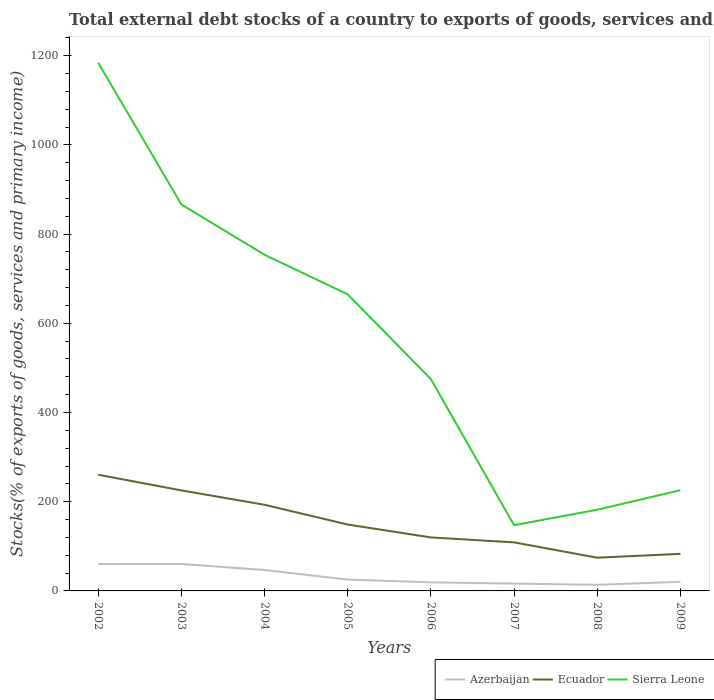Does the line corresponding to Ecuador intersect with the line corresponding to Azerbaijan?
Make the answer very short. No. Is the number of lines equal to the number of legend labels?
Make the answer very short. Yes. Across all years, what is the maximum total debt stocks in Azerbaijan?
Your response must be concise. 13.75. In which year was the total debt stocks in Ecuador maximum?
Provide a short and direct response. 2008. What is the total total debt stocks in Sierra Leone in the graph?
Offer a very short reply. 317.86. What is the difference between the highest and the second highest total debt stocks in Sierra Leone?
Provide a short and direct response. 1036.91. What is the difference between the highest and the lowest total debt stocks in Azerbaijan?
Offer a terse response. 3. Is the total debt stocks in Azerbaijan strictly greater than the total debt stocks in Ecuador over the years?
Offer a very short reply. Yes. How many lines are there?
Make the answer very short. 3. How many years are there in the graph?
Your response must be concise. 8. Where does the legend appear in the graph?
Provide a short and direct response. Bottom right. How many legend labels are there?
Keep it short and to the point. 3. What is the title of the graph?
Offer a terse response. Total external debt stocks of a country to exports of goods, services and primary income. Does "Croatia" appear as one of the legend labels in the graph?
Your answer should be very brief. No. What is the label or title of the X-axis?
Your response must be concise. Years. What is the label or title of the Y-axis?
Offer a terse response. Stocks(% of exports of goods, services and primary income). What is the Stocks(% of exports of goods, services and primary income) of Azerbaijan in 2002?
Your answer should be compact. 60.16. What is the Stocks(% of exports of goods, services and primary income) of Ecuador in 2002?
Offer a terse response. 260.5. What is the Stocks(% of exports of goods, services and primary income) of Sierra Leone in 2002?
Keep it short and to the point. 1184.31. What is the Stocks(% of exports of goods, services and primary income) in Azerbaijan in 2003?
Provide a short and direct response. 60.36. What is the Stocks(% of exports of goods, services and primary income) of Ecuador in 2003?
Give a very brief answer. 225.36. What is the Stocks(% of exports of goods, services and primary income) in Sierra Leone in 2003?
Make the answer very short. 866.46. What is the Stocks(% of exports of goods, services and primary income) of Azerbaijan in 2004?
Your answer should be very brief. 46.97. What is the Stocks(% of exports of goods, services and primary income) of Ecuador in 2004?
Your answer should be compact. 193.13. What is the Stocks(% of exports of goods, services and primary income) of Sierra Leone in 2004?
Give a very brief answer. 753.69. What is the Stocks(% of exports of goods, services and primary income) in Azerbaijan in 2005?
Give a very brief answer. 25.39. What is the Stocks(% of exports of goods, services and primary income) of Ecuador in 2005?
Offer a very short reply. 148.83. What is the Stocks(% of exports of goods, services and primary income) of Sierra Leone in 2005?
Your answer should be very brief. 664.88. What is the Stocks(% of exports of goods, services and primary income) of Azerbaijan in 2006?
Give a very brief answer. 19.2. What is the Stocks(% of exports of goods, services and primary income) of Ecuador in 2006?
Keep it short and to the point. 119.96. What is the Stocks(% of exports of goods, services and primary income) in Sierra Leone in 2006?
Provide a short and direct response. 474.84. What is the Stocks(% of exports of goods, services and primary income) of Azerbaijan in 2007?
Provide a short and direct response. 16.44. What is the Stocks(% of exports of goods, services and primary income) in Ecuador in 2007?
Provide a succinct answer. 108.87. What is the Stocks(% of exports of goods, services and primary income) of Sierra Leone in 2007?
Offer a very short reply. 147.41. What is the Stocks(% of exports of goods, services and primary income) in Azerbaijan in 2008?
Your answer should be very brief. 13.75. What is the Stocks(% of exports of goods, services and primary income) in Ecuador in 2008?
Provide a succinct answer. 74.46. What is the Stocks(% of exports of goods, services and primary income) of Sierra Leone in 2008?
Offer a very short reply. 182.07. What is the Stocks(% of exports of goods, services and primary income) in Azerbaijan in 2009?
Your response must be concise. 20.4. What is the Stocks(% of exports of goods, services and primary income) in Ecuador in 2009?
Your answer should be compact. 83.14. What is the Stocks(% of exports of goods, services and primary income) in Sierra Leone in 2009?
Your answer should be compact. 225.75. Across all years, what is the maximum Stocks(% of exports of goods, services and primary income) of Azerbaijan?
Your answer should be compact. 60.36. Across all years, what is the maximum Stocks(% of exports of goods, services and primary income) of Ecuador?
Offer a very short reply. 260.5. Across all years, what is the maximum Stocks(% of exports of goods, services and primary income) of Sierra Leone?
Provide a succinct answer. 1184.31. Across all years, what is the minimum Stocks(% of exports of goods, services and primary income) in Azerbaijan?
Ensure brevity in your answer.  13.75. Across all years, what is the minimum Stocks(% of exports of goods, services and primary income) in Ecuador?
Ensure brevity in your answer.  74.46. Across all years, what is the minimum Stocks(% of exports of goods, services and primary income) of Sierra Leone?
Ensure brevity in your answer.  147.41. What is the total Stocks(% of exports of goods, services and primary income) in Azerbaijan in the graph?
Ensure brevity in your answer.  262.67. What is the total Stocks(% of exports of goods, services and primary income) in Ecuador in the graph?
Your response must be concise. 1214.26. What is the total Stocks(% of exports of goods, services and primary income) of Sierra Leone in the graph?
Offer a terse response. 4499.4. What is the difference between the Stocks(% of exports of goods, services and primary income) of Azerbaijan in 2002 and that in 2003?
Provide a succinct answer. -0.19. What is the difference between the Stocks(% of exports of goods, services and primary income) in Ecuador in 2002 and that in 2003?
Provide a succinct answer. 35.14. What is the difference between the Stocks(% of exports of goods, services and primary income) of Sierra Leone in 2002 and that in 2003?
Make the answer very short. 317.86. What is the difference between the Stocks(% of exports of goods, services and primary income) in Azerbaijan in 2002 and that in 2004?
Your response must be concise. 13.2. What is the difference between the Stocks(% of exports of goods, services and primary income) of Ecuador in 2002 and that in 2004?
Provide a short and direct response. 67.37. What is the difference between the Stocks(% of exports of goods, services and primary income) in Sierra Leone in 2002 and that in 2004?
Offer a very short reply. 430.63. What is the difference between the Stocks(% of exports of goods, services and primary income) of Azerbaijan in 2002 and that in 2005?
Your response must be concise. 34.77. What is the difference between the Stocks(% of exports of goods, services and primary income) in Ecuador in 2002 and that in 2005?
Provide a short and direct response. 111.67. What is the difference between the Stocks(% of exports of goods, services and primary income) in Sierra Leone in 2002 and that in 2005?
Provide a short and direct response. 519.43. What is the difference between the Stocks(% of exports of goods, services and primary income) of Azerbaijan in 2002 and that in 2006?
Your answer should be very brief. 40.96. What is the difference between the Stocks(% of exports of goods, services and primary income) in Ecuador in 2002 and that in 2006?
Offer a very short reply. 140.54. What is the difference between the Stocks(% of exports of goods, services and primary income) of Sierra Leone in 2002 and that in 2006?
Keep it short and to the point. 709.48. What is the difference between the Stocks(% of exports of goods, services and primary income) in Azerbaijan in 2002 and that in 2007?
Make the answer very short. 43.73. What is the difference between the Stocks(% of exports of goods, services and primary income) of Ecuador in 2002 and that in 2007?
Keep it short and to the point. 151.63. What is the difference between the Stocks(% of exports of goods, services and primary income) of Sierra Leone in 2002 and that in 2007?
Provide a succinct answer. 1036.91. What is the difference between the Stocks(% of exports of goods, services and primary income) of Azerbaijan in 2002 and that in 2008?
Offer a very short reply. 46.42. What is the difference between the Stocks(% of exports of goods, services and primary income) of Ecuador in 2002 and that in 2008?
Your response must be concise. 186.04. What is the difference between the Stocks(% of exports of goods, services and primary income) of Sierra Leone in 2002 and that in 2008?
Make the answer very short. 1002.24. What is the difference between the Stocks(% of exports of goods, services and primary income) of Azerbaijan in 2002 and that in 2009?
Keep it short and to the point. 39.77. What is the difference between the Stocks(% of exports of goods, services and primary income) in Ecuador in 2002 and that in 2009?
Provide a succinct answer. 177.36. What is the difference between the Stocks(% of exports of goods, services and primary income) of Sierra Leone in 2002 and that in 2009?
Your answer should be compact. 958.57. What is the difference between the Stocks(% of exports of goods, services and primary income) in Azerbaijan in 2003 and that in 2004?
Your answer should be compact. 13.39. What is the difference between the Stocks(% of exports of goods, services and primary income) in Ecuador in 2003 and that in 2004?
Make the answer very short. 32.23. What is the difference between the Stocks(% of exports of goods, services and primary income) in Sierra Leone in 2003 and that in 2004?
Keep it short and to the point. 112.77. What is the difference between the Stocks(% of exports of goods, services and primary income) in Azerbaijan in 2003 and that in 2005?
Make the answer very short. 34.97. What is the difference between the Stocks(% of exports of goods, services and primary income) of Ecuador in 2003 and that in 2005?
Offer a terse response. 76.54. What is the difference between the Stocks(% of exports of goods, services and primary income) of Sierra Leone in 2003 and that in 2005?
Ensure brevity in your answer.  201.58. What is the difference between the Stocks(% of exports of goods, services and primary income) in Azerbaijan in 2003 and that in 2006?
Ensure brevity in your answer.  41.16. What is the difference between the Stocks(% of exports of goods, services and primary income) of Ecuador in 2003 and that in 2006?
Your answer should be compact. 105.4. What is the difference between the Stocks(% of exports of goods, services and primary income) of Sierra Leone in 2003 and that in 2006?
Make the answer very short. 391.62. What is the difference between the Stocks(% of exports of goods, services and primary income) of Azerbaijan in 2003 and that in 2007?
Offer a very short reply. 43.92. What is the difference between the Stocks(% of exports of goods, services and primary income) of Ecuador in 2003 and that in 2007?
Offer a terse response. 116.49. What is the difference between the Stocks(% of exports of goods, services and primary income) in Sierra Leone in 2003 and that in 2007?
Provide a succinct answer. 719.05. What is the difference between the Stocks(% of exports of goods, services and primary income) in Azerbaijan in 2003 and that in 2008?
Give a very brief answer. 46.61. What is the difference between the Stocks(% of exports of goods, services and primary income) of Ecuador in 2003 and that in 2008?
Your answer should be very brief. 150.9. What is the difference between the Stocks(% of exports of goods, services and primary income) of Sierra Leone in 2003 and that in 2008?
Ensure brevity in your answer.  684.39. What is the difference between the Stocks(% of exports of goods, services and primary income) in Azerbaijan in 2003 and that in 2009?
Give a very brief answer. 39.96. What is the difference between the Stocks(% of exports of goods, services and primary income) of Ecuador in 2003 and that in 2009?
Your answer should be compact. 142.22. What is the difference between the Stocks(% of exports of goods, services and primary income) of Sierra Leone in 2003 and that in 2009?
Give a very brief answer. 640.71. What is the difference between the Stocks(% of exports of goods, services and primary income) of Azerbaijan in 2004 and that in 2005?
Ensure brevity in your answer.  21.57. What is the difference between the Stocks(% of exports of goods, services and primary income) in Ecuador in 2004 and that in 2005?
Ensure brevity in your answer.  44.31. What is the difference between the Stocks(% of exports of goods, services and primary income) in Sierra Leone in 2004 and that in 2005?
Keep it short and to the point. 88.81. What is the difference between the Stocks(% of exports of goods, services and primary income) in Azerbaijan in 2004 and that in 2006?
Offer a very short reply. 27.76. What is the difference between the Stocks(% of exports of goods, services and primary income) of Ecuador in 2004 and that in 2006?
Your answer should be very brief. 73.17. What is the difference between the Stocks(% of exports of goods, services and primary income) in Sierra Leone in 2004 and that in 2006?
Provide a succinct answer. 278.85. What is the difference between the Stocks(% of exports of goods, services and primary income) of Azerbaijan in 2004 and that in 2007?
Provide a succinct answer. 30.53. What is the difference between the Stocks(% of exports of goods, services and primary income) in Ecuador in 2004 and that in 2007?
Offer a very short reply. 84.26. What is the difference between the Stocks(% of exports of goods, services and primary income) of Sierra Leone in 2004 and that in 2007?
Your answer should be very brief. 606.28. What is the difference between the Stocks(% of exports of goods, services and primary income) of Azerbaijan in 2004 and that in 2008?
Your answer should be compact. 33.22. What is the difference between the Stocks(% of exports of goods, services and primary income) in Ecuador in 2004 and that in 2008?
Your answer should be compact. 118.67. What is the difference between the Stocks(% of exports of goods, services and primary income) of Sierra Leone in 2004 and that in 2008?
Your response must be concise. 571.62. What is the difference between the Stocks(% of exports of goods, services and primary income) in Azerbaijan in 2004 and that in 2009?
Keep it short and to the point. 26.57. What is the difference between the Stocks(% of exports of goods, services and primary income) in Ecuador in 2004 and that in 2009?
Offer a terse response. 109.99. What is the difference between the Stocks(% of exports of goods, services and primary income) of Sierra Leone in 2004 and that in 2009?
Provide a short and direct response. 527.94. What is the difference between the Stocks(% of exports of goods, services and primary income) in Azerbaijan in 2005 and that in 2006?
Your answer should be very brief. 6.19. What is the difference between the Stocks(% of exports of goods, services and primary income) of Ecuador in 2005 and that in 2006?
Offer a very short reply. 28.87. What is the difference between the Stocks(% of exports of goods, services and primary income) of Sierra Leone in 2005 and that in 2006?
Keep it short and to the point. 190.05. What is the difference between the Stocks(% of exports of goods, services and primary income) in Azerbaijan in 2005 and that in 2007?
Give a very brief answer. 8.96. What is the difference between the Stocks(% of exports of goods, services and primary income) of Ecuador in 2005 and that in 2007?
Your response must be concise. 39.95. What is the difference between the Stocks(% of exports of goods, services and primary income) in Sierra Leone in 2005 and that in 2007?
Keep it short and to the point. 517.48. What is the difference between the Stocks(% of exports of goods, services and primary income) in Azerbaijan in 2005 and that in 2008?
Provide a succinct answer. 11.65. What is the difference between the Stocks(% of exports of goods, services and primary income) in Ecuador in 2005 and that in 2008?
Make the answer very short. 74.36. What is the difference between the Stocks(% of exports of goods, services and primary income) of Sierra Leone in 2005 and that in 2008?
Make the answer very short. 482.81. What is the difference between the Stocks(% of exports of goods, services and primary income) in Azerbaijan in 2005 and that in 2009?
Provide a short and direct response. 5. What is the difference between the Stocks(% of exports of goods, services and primary income) in Ecuador in 2005 and that in 2009?
Make the answer very short. 65.68. What is the difference between the Stocks(% of exports of goods, services and primary income) of Sierra Leone in 2005 and that in 2009?
Ensure brevity in your answer.  439.14. What is the difference between the Stocks(% of exports of goods, services and primary income) of Azerbaijan in 2006 and that in 2007?
Ensure brevity in your answer.  2.77. What is the difference between the Stocks(% of exports of goods, services and primary income) in Ecuador in 2006 and that in 2007?
Ensure brevity in your answer.  11.09. What is the difference between the Stocks(% of exports of goods, services and primary income) of Sierra Leone in 2006 and that in 2007?
Provide a succinct answer. 327.43. What is the difference between the Stocks(% of exports of goods, services and primary income) in Azerbaijan in 2006 and that in 2008?
Your answer should be very brief. 5.46. What is the difference between the Stocks(% of exports of goods, services and primary income) in Ecuador in 2006 and that in 2008?
Your response must be concise. 45.5. What is the difference between the Stocks(% of exports of goods, services and primary income) of Sierra Leone in 2006 and that in 2008?
Keep it short and to the point. 292.77. What is the difference between the Stocks(% of exports of goods, services and primary income) of Azerbaijan in 2006 and that in 2009?
Give a very brief answer. -1.19. What is the difference between the Stocks(% of exports of goods, services and primary income) in Ecuador in 2006 and that in 2009?
Provide a short and direct response. 36.82. What is the difference between the Stocks(% of exports of goods, services and primary income) of Sierra Leone in 2006 and that in 2009?
Your response must be concise. 249.09. What is the difference between the Stocks(% of exports of goods, services and primary income) in Azerbaijan in 2007 and that in 2008?
Give a very brief answer. 2.69. What is the difference between the Stocks(% of exports of goods, services and primary income) of Ecuador in 2007 and that in 2008?
Make the answer very short. 34.41. What is the difference between the Stocks(% of exports of goods, services and primary income) in Sierra Leone in 2007 and that in 2008?
Offer a very short reply. -34.66. What is the difference between the Stocks(% of exports of goods, services and primary income) of Azerbaijan in 2007 and that in 2009?
Offer a terse response. -3.96. What is the difference between the Stocks(% of exports of goods, services and primary income) in Ecuador in 2007 and that in 2009?
Offer a terse response. 25.73. What is the difference between the Stocks(% of exports of goods, services and primary income) in Sierra Leone in 2007 and that in 2009?
Ensure brevity in your answer.  -78.34. What is the difference between the Stocks(% of exports of goods, services and primary income) in Azerbaijan in 2008 and that in 2009?
Give a very brief answer. -6.65. What is the difference between the Stocks(% of exports of goods, services and primary income) of Ecuador in 2008 and that in 2009?
Your answer should be compact. -8.68. What is the difference between the Stocks(% of exports of goods, services and primary income) of Sierra Leone in 2008 and that in 2009?
Ensure brevity in your answer.  -43.68. What is the difference between the Stocks(% of exports of goods, services and primary income) of Azerbaijan in 2002 and the Stocks(% of exports of goods, services and primary income) of Ecuador in 2003?
Your response must be concise. -165.2. What is the difference between the Stocks(% of exports of goods, services and primary income) of Azerbaijan in 2002 and the Stocks(% of exports of goods, services and primary income) of Sierra Leone in 2003?
Offer a very short reply. -806.29. What is the difference between the Stocks(% of exports of goods, services and primary income) in Ecuador in 2002 and the Stocks(% of exports of goods, services and primary income) in Sierra Leone in 2003?
Provide a short and direct response. -605.96. What is the difference between the Stocks(% of exports of goods, services and primary income) of Azerbaijan in 2002 and the Stocks(% of exports of goods, services and primary income) of Ecuador in 2004?
Your response must be concise. -132.97. What is the difference between the Stocks(% of exports of goods, services and primary income) of Azerbaijan in 2002 and the Stocks(% of exports of goods, services and primary income) of Sierra Leone in 2004?
Your response must be concise. -693.52. What is the difference between the Stocks(% of exports of goods, services and primary income) of Ecuador in 2002 and the Stocks(% of exports of goods, services and primary income) of Sierra Leone in 2004?
Offer a terse response. -493.19. What is the difference between the Stocks(% of exports of goods, services and primary income) of Azerbaijan in 2002 and the Stocks(% of exports of goods, services and primary income) of Ecuador in 2005?
Your answer should be compact. -88.66. What is the difference between the Stocks(% of exports of goods, services and primary income) of Azerbaijan in 2002 and the Stocks(% of exports of goods, services and primary income) of Sierra Leone in 2005?
Your answer should be very brief. -604.72. What is the difference between the Stocks(% of exports of goods, services and primary income) of Ecuador in 2002 and the Stocks(% of exports of goods, services and primary income) of Sierra Leone in 2005?
Provide a succinct answer. -404.38. What is the difference between the Stocks(% of exports of goods, services and primary income) in Azerbaijan in 2002 and the Stocks(% of exports of goods, services and primary income) in Ecuador in 2006?
Provide a succinct answer. -59.79. What is the difference between the Stocks(% of exports of goods, services and primary income) in Azerbaijan in 2002 and the Stocks(% of exports of goods, services and primary income) in Sierra Leone in 2006?
Provide a short and direct response. -414.67. What is the difference between the Stocks(% of exports of goods, services and primary income) in Ecuador in 2002 and the Stocks(% of exports of goods, services and primary income) in Sierra Leone in 2006?
Keep it short and to the point. -214.34. What is the difference between the Stocks(% of exports of goods, services and primary income) in Azerbaijan in 2002 and the Stocks(% of exports of goods, services and primary income) in Ecuador in 2007?
Make the answer very short. -48.71. What is the difference between the Stocks(% of exports of goods, services and primary income) in Azerbaijan in 2002 and the Stocks(% of exports of goods, services and primary income) in Sierra Leone in 2007?
Provide a succinct answer. -87.24. What is the difference between the Stocks(% of exports of goods, services and primary income) of Ecuador in 2002 and the Stocks(% of exports of goods, services and primary income) of Sierra Leone in 2007?
Ensure brevity in your answer.  113.09. What is the difference between the Stocks(% of exports of goods, services and primary income) of Azerbaijan in 2002 and the Stocks(% of exports of goods, services and primary income) of Ecuador in 2008?
Keep it short and to the point. -14.3. What is the difference between the Stocks(% of exports of goods, services and primary income) of Azerbaijan in 2002 and the Stocks(% of exports of goods, services and primary income) of Sierra Leone in 2008?
Provide a succinct answer. -121.9. What is the difference between the Stocks(% of exports of goods, services and primary income) in Ecuador in 2002 and the Stocks(% of exports of goods, services and primary income) in Sierra Leone in 2008?
Your answer should be very brief. 78.43. What is the difference between the Stocks(% of exports of goods, services and primary income) of Azerbaijan in 2002 and the Stocks(% of exports of goods, services and primary income) of Ecuador in 2009?
Make the answer very short. -22.98. What is the difference between the Stocks(% of exports of goods, services and primary income) of Azerbaijan in 2002 and the Stocks(% of exports of goods, services and primary income) of Sierra Leone in 2009?
Your answer should be compact. -165.58. What is the difference between the Stocks(% of exports of goods, services and primary income) in Ecuador in 2002 and the Stocks(% of exports of goods, services and primary income) in Sierra Leone in 2009?
Offer a very short reply. 34.75. What is the difference between the Stocks(% of exports of goods, services and primary income) of Azerbaijan in 2003 and the Stocks(% of exports of goods, services and primary income) of Ecuador in 2004?
Make the answer very short. -132.77. What is the difference between the Stocks(% of exports of goods, services and primary income) in Azerbaijan in 2003 and the Stocks(% of exports of goods, services and primary income) in Sierra Leone in 2004?
Keep it short and to the point. -693.33. What is the difference between the Stocks(% of exports of goods, services and primary income) of Ecuador in 2003 and the Stocks(% of exports of goods, services and primary income) of Sierra Leone in 2004?
Offer a very short reply. -528.33. What is the difference between the Stocks(% of exports of goods, services and primary income) of Azerbaijan in 2003 and the Stocks(% of exports of goods, services and primary income) of Ecuador in 2005?
Keep it short and to the point. -88.47. What is the difference between the Stocks(% of exports of goods, services and primary income) of Azerbaijan in 2003 and the Stocks(% of exports of goods, services and primary income) of Sierra Leone in 2005?
Your answer should be very brief. -604.52. What is the difference between the Stocks(% of exports of goods, services and primary income) in Ecuador in 2003 and the Stocks(% of exports of goods, services and primary income) in Sierra Leone in 2005?
Provide a succinct answer. -439.52. What is the difference between the Stocks(% of exports of goods, services and primary income) in Azerbaijan in 2003 and the Stocks(% of exports of goods, services and primary income) in Ecuador in 2006?
Give a very brief answer. -59.6. What is the difference between the Stocks(% of exports of goods, services and primary income) of Azerbaijan in 2003 and the Stocks(% of exports of goods, services and primary income) of Sierra Leone in 2006?
Provide a short and direct response. -414.48. What is the difference between the Stocks(% of exports of goods, services and primary income) in Ecuador in 2003 and the Stocks(% of exports of goods, services and primary income) in Sierra Leone in 2006?
Your response must be concise. -249.47. What is the difference between the Stocks(% of exports of goods, services and primary income) of Azerbaijan in 2003 and the Stocks(% of exports of goods, services and primary income) of Ecuador in 2007?
Your response must be concise. -48.51. What is the difference between the Stocks(% of exports of goods, services and primary income) of Azerbaijan in 2003 and the Stocks(% of exports of goods, services and primary income) of Sierra Leone in 2007?
Keep it short and to the point. -87.05. What is the difference between the Stocks(% of exports of goods, services and primary income) of Ecuador in 2003 and the Stocks(% of exports of goods, services and primary income) of Sierra Leone in 2007?
Give a very brief answer. 77.95. What is the difference between the Stocks(% of exports of goods, services and primary income) of Azerbaijan in 2003 and the Stocks(% of exports of goods, services and primary income) of Ecuador in 2008?
Your answer should be very brief. -14.1. What is the difference between the Stocks(% of exports of goods, services and primary income) of Azerbaijan in 2003 and the Stocks(% of exports of goods, services and primary income) of Sierra Leone in 2008?
Offer a very short reply. -121.71. What is the difference between the Stocks(% of exports of goods, services and primary income) in Ecuador in 2003 and the Stocks(% of exports of goods, services and primary income) in Sierra Leone in 2008?
Keep it short and to the point. 43.29. What is the difference between the Stocks(% of exports of goods, services and primary income) of Azerbaijan in 2003 and the Stocks(% of exports of goods, services and primary income) of Ecuador in 2009?
Provide a succinct answer. -22.78. What is the difference between the Stocks(% of exports of goods, services and primary income) in Azerbaijan in 2003 and the Stocks(% of exports of goods, services and primary income) in Sierra Leone in 2009?
Give a very brief answer. -165.39. What is the difference between the Stocks(% of exports of goods, services and primary income) in Ecuador in 2003 and the Stocks(% of exports of goods, services and primary income) in Sierra Leone in 2009?
Give a very brief answer. -0.39. What is the difference between the Stocks(% of exports of goods, services and primary income) of Azerbaijan in 2004 and the Stocks(% of exports of goods, services and primary income) of Ecuador in 2005?
Keep it short and to the point. -101.86. What is the difference between the Stocks(% of exports of goods, services and primary income) of Azerbaijan in 2004 and the Stocks(% of exports of goods, services and primary income) of Sierra Leone in 2005?
Give a very brief answer. -617.91. What is the difference between the Stocks(% of exports of goods, services and primary income) of Ecuador in 2004 and the Stocks(% of exports of goods, services and primary income) of Sierra Leone in 2005?
Offer a terse response. -471.75. What is the difference between the Stocks(% of exports of goods, services and primary income) in Azerbaijan in 2004 and the Stocks(% of exports of goods, services and primary income) in Ecuador in 2006?
Provide a short and direct response. -72.99. What is the difference between the Stocks(% of exports of goods, services and primary income) in Azerbaijan in 2004 and the Stocks(% of exports of goods, services and primary income) in Sierra Leone in 2006?
Provide a succinct answer. -427.87. What is the difference between the Stocks(% of exports of goods, services and primary income) in Ecuador in 2004 and the Stocks(% of exports of goods, services and primary income) in Sierra Leone in 2006?
Offer a terse response. -281.7. What is the difference between the Stocks(% of exports of goods, services and primary income) of Azerbaijan in 2004 and the Stocks(% of exports of goods, services and primary income) of Ecuador in 2007?
Give a very brief answer. -61.9. What is the difference between the Stocks(% of exports of goods, services and primary income) of Azerbaijan in 2004 and the Stocks(% of exports of goods, services and primary income) of Sierra Leone in 2007?
Provide a succinct answer. -100.44. What is the difference between the Stocks(% of exports of goods, services and primary income) of Ecuador in 2004 and the Stocks(% of exports of goods, services and primary income) of Sierra Leone in 2007?
Your answer should be very brief. 45.73. What is the difference between the Stocks(% of exports of goods, services and primary income) of Azerbaijan in 2004 and the Stocks(% of exports of goods, services and primary income) of Ecuador in 2008?
Provide a succinct answer. -27.5. What is the difference between the Stocks(% of exports of goods, services and primary income) of Azerbaijan in 2004 and the Stocks(% of exports of goods, services and primary income) of Sierra Leone in 2008?
Offer a terse response. -135.1. What is the difference between the Stocks(% of exports of goods, services and primary income) of Ecuador in 2004 and the Stocks(% of exports of goods, services and primary income) of Sierra Leone in 2008?
Provide a short and direct response. 11.06. What is the difference between the Stocks(% of exports of goods, services and primary income) of Azerbaijan in 2004 and the Stocks(% of exports of goods, services and primary income) of Ecuador in 2009?
Offer a terse response. -36.17. What is the difference between the Stocks(% of exports of goods, services and primary income) of Azerbaijan in 2004 and the Stocks(% of exports of goods, services and primary income) of Sierra Leone in 2009?
Offer a very short reply. -178.78. What is the difference between the Stocks(% of exports of goods, services and primary income) in Ecuador in 2004 and the Stocks(% of exports of goods, services and primary income) in Sierra Leone in 2009?
Your answer should be compact. -32.61. What is the difference between the Stocks(% of exports of goods, services and primary income) of Azerbaijan in 2005 and the Stocks(% of exports of goods, services and primary income) of Ecuador in 2006?
Give a very brief answer. -94.57. What is the difference between the Stocks(% of exports of goods, services and primary income) in Azerbaijan in 2005 and the Stocks(% of exports of goods, services and primary income) in Sierra Leone in 2006?
Keep it short and to the point. -449.44. What is the difference between the Stocks(% of exports of goods, services and primary income) in Ecuador in 2005 and the Stocks(% of exports of goods, services and primary income) in Sierra Leone in 2006?
Keep it short and to the point. -326.01. What is the difference between the Stocks(% of exports of goods, services and primary income) in Azerbaijan in 2005 and the Stocks(% of exports of goods, services and primary income) in Ecuador in 2007?
Provide a succinct answer. -83.48. What is the difference between the Stocks(% of exports of goods, services and primary income) in Azerbaijan in 2005 and the Stocks(% of exports of goods, services and primary income) in Sierra Leone in 2007?
Your response must be concise. -122.01. What is the difference between the Stocks(% of exports of goods, services and primary income) of Ecuador in 2005 and the Stocks(% of exports of goods, services and primary income) of Sierra Leone in 2007?
Offer a terse response. 1.42. What is the difference between the Stocks(% of exports of goods, services and primary income) of Azerbaijan in 2005 and the Stocks(% of exports of goods, services and primary income) of Ecuador in 2008?
Offer a terse response. -49.07. What is the difference between the Stocks(% of exports of goods, services and primary income) of Azerbaijan in 2005 and the Stocks(% of exports of goods, services and primary income) of Sierra Leone in 2008?
Make the answer very short. -156.68. What is the difference between the Stocks(% of exports of goods, services and primary income) in Ecuador in 2005 and the Stocks(% of exports of goods, services and primary income) in Sierra Leone in 2008?
Offer a very short reply. -33.24. What is the difference between the Stocks(% of exports of goods, services and primary income) in Azerbaijan in 2005 and the Stocks(% of exports of goods, services and primary income) in Ecuador in 2009?
Your response must be concise. -57.75. What is the difference between the Stocks(% of exports of goods, services and primary income) in Azerbaijan in 2005 and the Stocks(% of exports of goods, services and primary income) in Sierra Leone in 2009?
Keep it short and to the point. -200.35. What is the difference between the Stocks(% of exports of goods, services and primary income) in Ecuador in 2005 and the Stocks(% of exports of goods, services and primary income) in Sierra Leone in 2009?
Provide a short and direct response. -76.92. What is the difference between the Stocks(% of exports of goods, services and primary income) in Azerbaijan in 2006 and the Stocks(% of exports of goods, services and primary income) in Ecuador in 2007?
Offer a very short reply. -89.67. What is the difference between the Stocks(% of exports of goods, services and primary income) in Azerbaijan in 2006 and the Stocks(% of exports of goods, services and primary income) in Sierra Leone in 2007?
Ensure brevity in your answer.  -128.2. What is the difference between the Stocks(% of exports of goods, services and primary income) of Ecuador in 2006 and the Stocks(% of exports of goods, services and primary income) of Sierra Leone in 2007?
Offer a very short reply. -27.45. What is the difference between the Stocks(% of exports of goods, services and primary income) of Azerbaijan in 2006 and the Stocks(% of exports of goods, services and primary income) of Ecuador in 2008?
Your answer should be very brief. -55.26. What is the difference between the Stocks(% of exports of goods, services and primary income) in Azerbaijan in 2006 and the Stocks(% of exports of goods, services and primary income) in Sierra Leone in 2008?
Provide a succinct answer. -162.87. What is the difference between the Stocks(% of exports of goods, services and primary income) of Ecuador in 2006 and the Stocks(% of exports of goods, services and primary income) of Sierra Leone in 2008?
Offer a very short reply. -62.11. What is the difference between the Stocks(% of exports of goods, services and primary income) in Azerbaijan in 2006 and the Stocks(% of exports of goods, services and primary income) in Ecuador in 2009?
Your answer should be very brief. -63.94. What is the difference between the Stocks(% of exports of goods, services and primary income) in Azerbaijan in 2006 and the Stocks(% of exports of goods, services and primary income) in Sierra Leone in 2009?
Your answer should be compact. -206.54. What is the difference between the Stocks(% of exports of goods, services and primary income) in Ecuador in 2006 and the Stocks(% of exports of goods, services and primary income) in Sierra Leone in 2009?
Keep it short and to the point. -105.79. What is the difference between the Stocks(% of exports of goods, services and primary income) in Azerbaijan in 2007 and the Stocks(% of exports of goods, services and primary income) in Ecuador in 2008?
Your response must be concise. -58.03. What is the difference between the Stocks(% of exports of goods, services and primary income) in Azerbaijan in 2007 and the Stocks(% of exports of goods, services and primary income) in Sierra Leone in 2008?
Your answer should be very brief. -165.63. What is the difference between the Stocks(% of exports of goods, services and primary income) of Ecuador in 2007 and the Stocks(% of exports of goods, services and primary income) of Sierra Leone in 2008?
Offer a very short reply. -73.2. What is the difference between the Stocks(% of exports of goods, services and primary income) in Azerbaijan in 2007 and the Stocks(% of exports of goods, services and primary income) in Ecuador in 2009?
Keep it short and to the point. -66.7. What is the difference between the Stocks(% of exports of goods, services and primary income) in Azerbaijan in 2007 and the Stocks(% of exports of goods, services and primary income) in Sierra Leone in 2009?
Your answer should be compact. -209.31. What is the difference between the Stocks(% of exports of goods, services and primary income) in Ecuador in 2007 and the Stocks(% of exports of goods, services and primary income) in Sierra Leone in 2009?
Offer a terse response. -116.88. What is the difference between the Stocks(% of exports of goods, services and primary income) in Azerbaijan in 2008 and the Stocks(% of exports of goods, services and primary income) in Ecuador in 2009?
Your answer should be compact. -69.39. What is the difference between the Stocks(% of exports of goods, services and primary income) of Azerbaijan in 2008 and the Stocks(% of exports of goods, services and primary income) of Sierra Leone in 2009?
Your response must be concise. -212. What is the difference between the Stocks(% of exports of goods, services and primary income) of Ecuador in 2008 and the Stocks(% of exports of goods, services and primary income) of Sierra Leone in 2009?
Keep it short and to the point. -151.28. What is the average Stocks(% of exports of goods, services and primary income) in Azerbaijan per year?
Make the answer very short. 32.83. What is the average Stocks(% of exports of goods, services and primary income) in Ecuador per year?
Ensure brevity in your answer.  151.78. What is the average Stocks(% of exports of goods, services and primary income) in Sierra Leone per year?
Ensure brevity in your answer.  562.43. In the year 2002, what is the difference between the Stocks(% of exports of goods, services and primary income) of Azerbaijan and Stocks(% of exports of goods, services and primary income) of Ecuador?
Offer a very short reply. -200.33. In the year 2002, what is the difference between the Stocks(% of exports of goods, services and primary income) in Azerbaijan and Stocks(% of exports of goods, services and primary income) in Sierra Leone?
Your answer should be compact. -1124.15. In the year 2002, what is the difference between the Stocks(% of exports of goods, services and primary income) in Ecuador and Stocks(% of exports of goods, services and primary income) in Sierra Leone?
Your response must be concise. -923.81. In the year 2003, what is the difference between the Stocks(% of exports of goods, services and primary income) of Azerbaijan and Stocks(% of exports of goods, services and primary income) of Ecuador?
Provide a short and direct response. -165. In the year 2003, what is the difference between the Stocks(% of exports of goods, services and primary income) of Azerbaijan and Stocks(% of exports of goods, services and primary income) of Sierra Leone?
Keep it short and to the point. -806.1. In the year 2003, what is the difference between the Stocks(% of exports of goods, services and primary income) of Ecuador and Stocks(% of exports of goods, services and primary income) of Sierra Leone?
Provide a short and direct response. -641.1. In the year 2004, what is the difference between the Stocks(% of exports of goods, services and primary income) of Azerbaijan and Stocks(% of exports of goods, services and primary income) of Ecuador?
Provide a succinct answer. -146.17. In the year 2004, what is the difference between the Stocks(% of exports of goods, services and primary income) of Azerbaijan and Stocks(% of exports of goods, services and primary income) of Sierra Leone?
Provide a short and direct response. -706.72. In the year 2004, what is the difference between the Stocks(% of exports of goods, services and primary income) in Ecuador and Stocks(% of exports of goods, services and primary income) in Sierra Leone?
Offer a terse response. -560.55. In the year 2005, what is the difference between the Stocks(% of exports of goods, services and primary income) of Azerbaijan and Stocks(% of exports of goods, services and primary income) of Ecuador?
Your answer should be compact. -123.43. In the year 2005, what is the difference between the Stocks(% of exports of goods, services and primary income) of Azerbaijan and Stocks(% of exports of goods, services and primary income) of Sierra Leone?
Provide a short and direct response. -639.49. In the year 2005, what is the difference between the Stocks(% of exports of goods, services and primary income) of Ecuador and Stocks(% of exports of goods, services and primary income) of Sierra Leone?
Give a very brief answer. -516.06. In the year 2006, what is the difference between the Stocks(% of exports of goods, services and primary income) in Azerbaijan and Stocks(% of exports of goods, services and primary income) in Ecuador?
Give a very brief answer. -100.76. In the year 2006, what is the difference between the Stocks(% of exports of goods, services and primary income) in Azerbaijan and Stocks(% of exports of goods, services and primary income) in Sierra Leone?
Your answer should be compact. -455.63. In the year 2006, what is the difference between the Stocks(% of exports of goods, services and primary income) in Ecuador and Stocks(% of exports of goods, services and primary income) in Sierra Leone?
Your response must be concise. -354.88. In the year 2007, what is the difference between the Stocks(% of exports of goods, services and primary income) in Azerbaijan and Stocks(% of exports of goods, services and primary income) in Ecuador?
Your response must be concise. -92.43. In the year 2007, what is the difference between the Stocks(% of exports of goods, services and primary income) of Azerbaijan and Stocks(% of exports of goods, services and primary income) of Sierra Leone?
Your answer should be very brief. -130.97. In the year 2007, what is the difference between the Stocks(% of exports of goods, services and primary income) in Ecuador and Stocks(% of exports of goods, services and primary income) in Sierra Leone?
Keep it short and to the point. -38.54. In the year 2008, what is the difference between the Stocks(% of exports of goods, services and primary income) of Azerbaijan and Stocks(% of exports of goods, services and primary income) of Ecuador?
Ensure brevity in your answer.  -60.72. In the year 2008, what is the difference between the Stocks(% of exports of goods, services and primary income) in Azerbaijan and Stocks(% of exports of goods, services and primary income) in Sierra Leone?
Your answer should be compact. -168.32. In the year 2008, what is the difference between the Stocks(% of exports of goods, services and primary income) in Ecuador and Stocks(% of exports of goods, services and primary income) in Sierra Leone?
Make the answer very short. -107.61. In the year 2009, what is the difference between the Stocks(% of exports of goods, services and primary income) of Azerbaijan and Stocks(% of exports of goods, services and primary income) of Ecuador?
Provide a short and direct response. -62.75. In the year 2009, what is the difference between the Stocks(% of exports of goods, services and primary income) of Azerbaijan and Stocks(% of exports of goods, services and primary income) of Sierra Leone?
Provide a succinct answer. -205.35. In the year 2009, what is the difference between the Stocks(% of exports of goods, services and primary income) in Ecuador and Stocks(% of exports of goods, services and primary income) in Sierra Leone?
Ensure brevity in your answer.  -142.61. What is the ratio of the Stocks(% of exports of goods, services and primary income) in Ecuador in 2002 to that in 2003?
Offer a terse response. 1.16. What is the ratio of the Stocks(% of exports of goods, services and primary income) in Sierra Leone in 2002 to that in 2003?
Make the answer very short. 1.37. What is the ratio of the Stocks(% of exports of goods, services and primary income) of Azerbaijan in 2002 to that in 2004?
Make the answer very short. 1.28. What is the ratio of the Stocks(% of exports of goods, services and primary income) of Ecuador in 2002 to that in 2004?
Give a very brief answer. 1.35. What is the ratio of the Stocks(% of exports of goods, services and primary income) in Sierra Leone in 2002 to that in 2004?
Ensure brevity in your answer.  1.57. What is the ratio of the Stocks(% of exports of goods, services and primary income) of Azerbaijan in 2002 to that in 2005?
Your answer should be very brief. 2.37. What is the ratio of the Stocks(% of exports of goods, services and primary income) in Ecuador in 2002 to that in 2005?
Offer a terse response. 1.75. What is the ratio of the Stocks(% of exports of goods, services and primary income) in Sierra Leone in 2002 to that in 2005?
Offer a very short reply. 1.78. What is the ratio of the Stocks(% of exports of goods, services and primary income) of Azerbaijan in 2002 to that in 2006?
Provide a succinct answer. 3.13. What is the ratio of the Stocks(% of exports of goods, services and primary income) of Ecuador in 2002 to that in 2006?
Offer a terse response. 2.17. What is the ratio of the Stocks(% of exports of goods, services and primary income) of Sierra Leone in 2002 to that in 2006?
Provide a short and direct response. 2.49. What is the ratio of the Stocks(% of exports of goods, services and primary income) of Azerbaijan in 2002 to that in 2007?
Ensure brevity in your answer.  3.66. What is the ratio of the Stocks(% of exports of goods, services and primary income) of Ecuador in 2002 to that in 2007?
Offer a very short reply. 2.39. What is the ratio of the Stocks(% of exports of goods, services and primary income) in Sierra Leone in 2002 to that in 2007?
Make the answer very short. 8.03. What is the ratio of the Stocks(% of exports of goods, services and primary income) in Azerbaijan in 2002 to that in 2008?
Offer a terse response. 4.38. What is the ratio of the Stocks(% of exports of goods, services and primary income) of Ecuador in 2002 to that in 2008?
Keep it short and to the point. 3.5. What is the ratio of the Stocks(% of exports of goods, services and primary income) of Sierra Leone in 2002 to that in 2008?
Your answer should be very brief. 6.5. What is the ratio of the Stocks(% of exports of goods, services and primary income) in Azerbaijan in 2002 to that in 2009?
Make the answer very short. 2.95. What is the ratio of the Stocks(% of exports of goods, services and primary income) of Ecuador in 2002 to that in 2009?
Ensure brevity in your answer.  3.13. What is the ratio of the Stocks(% of exports of goods, services and primary income) of Sierra Leone in 2002 to that in 2009?
Provide a short and direct response. 5.25. What is the ratio of the Stocks(% of exports of goods, services and primary income) of Azerbaijan in 2003 to that in 2004?
Provide a succinct answer. 1.29. What is the ratio of the Stocks(% of exports of goods, services and primary income) of Ecuador in 2003 to that in 2004?
Provide a succinct answer. 1.17. What is the ratio of the Stocks(% of exports of goods, services and primary income) in Sierra Leone in 2003 to that in 2004?
Provide a succinct answer. 1.15. What is the ratio of the Stocks(% of exports of goods, services and primary income) of Azerbaijan in 2003 to that in 2005?
Provide a short and direct response. 2.38. What is the ratio of the Stocks(% of exports of goods, services and primary income) of Ecuador in 2003 to that in 2005?
Provide a short and direct response. 1.51. What is the ratio of the Stocks(% of exports of goods, services and primary income) in Sierra Leone in 2003 to that in 2005?
Ensure brevity in your answer.  1.3. What is the ratio of the Stocks(% of exports of goods, services and primary income) in Azerbaijan in 2003 to that in 2006?
Provide a succinct answer. 3.14. What is the ratio of the Stocks(% of exports of goods, services and primary income) in Ecuador in 2003 to that in 2006?
Give a very brief answer. 1.88. What is the ratio of the Stocks(% of exports of goods, services and primary income) in Sierra Leone in 2003 to that in 2006?
Give a very brief answer. 1.82. What is the ratio of the Stocks(% of exports of goods, services and primary income) of Azerbaijan in 2003 to that in 2007?
Your answer should be compact. 3.67. What is the ratio of the Stocks(% of exports of goods, services and primary income) of Ecuador in 2003 to that in 2007?
Ensure brevity in your answer.  2.07. What is the ratio of the Stocks(% of exports of goods, services and primary income) of Sierra Leone in 2003 to that in 2007?
Offer a terse response. 5.88. What is the ratio of the Stocks(% of exports of goods, services and primary income) in Azerbaijan in 2003 to that in 2008?
Offer a terse response. 4.39. What is the ratio of the Stocks(% of exports of goods, services and primary income) in Ecuador in 2003 to that in 2008?
Make the answer very short. 3.03. What is the ratio of the Stocks(% of exports of goods, services and primary income) in Sierra Leone in 2003 to that in 2008?
Provide a succinct answer. 4.76. What is the ratio of the Stocks(% of exports of goods, services and primary income) of Azerbaijan in 2003 to that in 2009?
Provide a succinct answer. 2.96. What is the ratio of the Stocks(% of exports of goods, services and primary income) in Ecuador in 2003 to that in 2009?
Your answer should be very brief. 2.71. What is the ratio of the Stocks(% of exports of goods, services and primary income) of Sierra Leone in 2003 to that in 2009?
Make the answer very short. 3.84. What is the ratio of the Stocks(% of exports of goods, services and primary income) in Azerbaijan in 2004 to that in 2005?
Provide a succinct answer. 1.85. What is the ratio of the Stocks(% of exports of goods, services and primary income) in Ecuador in 2004 to that in 2005?
Your answer should be very brief. 1.3. What is the ratio of the Stocks(% of exports of goods, services and primary income) of Sierra Leone in 2004 to that in 2005?
Offer a very short reply. 1.13. What is the ratio of the Stocks(% of exports of goods, services and primary income) of Azerbaijan in 2004 to that in 2006?
Keep it short and to the point. 2.45. What is the ratio of the Stocks(% of exports of goods, services and primary income) of Ecuador in 2004 to that in 2006?
Your response must be concise. 1.61. What is the ratio of the Stocks(% of exports of goods, services and primary income) of Sierra Leone in 2004 to that in 2006?
Keep it short and to the point. 1.59. What is the ratio of the Stocks(% of exports of goods, services and primary income) of Azerbaijan in 2004 to that in 2007?
Offer a terse response. 2.86. What is the ratio of the Stocks(% of exports of goods, services and primary income) of Ecuador in 2004 to that in 2007?
Your answer should be very brief. 1.77. What is the ratio of the Stocks(% of exports of goods, services and primary income) in Sierra Leone in 2004 to that in 2007?
Your response must be concise. 5.11. What is the ratio of the Stocks(% of exports of goods, services and primary income) in Azerbaijan in 2004 to that in 2008?
Provide a succinct answer. 3.42. What is the ratio of the Stocks(% of exports of goods, services and primary income) of Ecuador in 2004 to that in 2008?
Your response must be concise. 2.59. What is the ratio of the Stocks(% of exports of goods, services and primary income) in Sierra Leone in 2004 to that in 2008?
Offer a terse response. 4.14. What is the ratio of the Stocks(% of exports of goods, services and primary income) of Azerbaijan in 2004 to that in 2009?
Provide a short and direct response. 2.3. What is the ratio of the Stocks(% of exports of goods, services and primary income) of Ecuador in 2004 to that in 2009?
Ensure brevity in your answer.  2.32. What is the ratio of the Stocks(% of exports of goods, services and primary income) in Sierra Leone in 2004 to that in 2009?
Keep it short and to the point. 3.34. What is the ratio of the Stocks(% of exports of goods, services and primary income) in Azerbaijan in 2005 to that in 2006?
Your answer should be very brief. 1.32. What is the ratio of the Stocks(% of exports of goods, services and primary income) in Ecuador in 2005 to that in 2006?
Your answer should be compact. 1.24. What is the ratio of the Stocks(% of exports of goods, services and primary income) in Sierra Leone in 2005 to that in 2006?
Offer a very short reply. 1.4. What is the ratio of the Stocks(% of exports of goods, services and primary income) of Azerbaijan in 2005 to that in 2007?
Your answer should be compact. 1.54. What is the ratio of the Stocks(% of exports of goods, services and primary income) in Ecuador in 2005 to that in 2007?
Ensure brevity in your answer.  1.37. What is the ratio of the Stocks(% of exports of goods, services and primary income) in Sierra Leone in 2005 to that in 2007?
Ensure brevity in your answer.  4.51. What is the ratio of the Stocks(% of exports of goods, services and primary income) in Azerbaijan in 2005 to that in 2008?
Your response must be concise. 1.85. What is the ratio of the Stocks(% of exports of goods, services and primary income) of Ecuador in 2005 to that in 2008?
Your answer should be compact. 2. What is the ratio of the Stocks(% of exports of goods, services and primary income) in Sierra Leone in 2005 to that in 2008?
Give a very brief answer. 3.65. What is the ratio of the Stocks(% of exports of goods, services and primary income) of Azerbaijan in 2005 to that in 2009?
Give a very brief answer. 1.25. What is the ratio of the Stocks(% of exports of goods, services and primary income) of Ecuador in 2005 to that in 2009?
Your answer should be compact. 1.79. What is the ratio of the Stocks(% of exports of goods, services and primary income) of Sierra Leone in 2005 to that in 2009?
Make the answer very short. 2.95. What is the ratio of the Stocks(% of exports of goods, services and primary income) of Azerbaijan in 2006 to that in 2007?
Offer a terse response. 1.17. What is the ratio of the Stocks(% of exports of goods, services and primary income) of Ecuador in 2006 to that in 2007?
Your answer should be compact. 1.1. What is the ratio of the Stocks(% of exports of goods, services and primary income) of Sierra Leone in 2006 to that in 2007?
Your response must be concise. 3.22. What is the ratio of the Stocks(% of exports of goods, services and primary income) in Azerbaijan in 2006 to that in 2008?
Provide a succinct answer. 1.4. What is the ratio of the Stocks(% of exports of goods, services and primary income) of Ecuador in 2006 to that in 2008?
Give a very brief answer. 1.61. What is the ratio of the Stocks(% of exports of goods, services and primary income) of Sierra Leone in 2006 to that in 2008?
Offer a terse response. 2.61. What is the ratio of the Stocks(% of exports of goods, services and primary income) of Azerbaijan in 2006 to that in 2009?
Offer a terse response. 0.94. What is the ratio of the Stocks(% of exports of goods, services and primary income) in Ecuador in 2006 to that in 2009?
Keep it short and to the point. 1.44. What is the ratio of the Stocks(% of exports of goods, services and primary income) of Sierra Leone in 2006 to that in 2009?
Offer a very short reply. 2.1. What is the ratio of the Stocks(% of exports of goods, services and primary income) in Azerbaijan in 2007 to that in 2008?
Make the answer very short. 1.2. What is the ratio of the Stocks(% of exports of goods, services and primary income) in Ecuador in 2007 to that in 2008?
Keep it short and to the point. 1.46. What is the ratio of the Stocks(% of exports of goods, services and primary income) of Sierra Leone in 2007 to that in 2008?
Give a very brief answer. 0.81. What is the ratio of the Stocks(% of exports of goods, services and primary income) of Azerbaijan in 2007 to that in 2009?
Keep it short and to the point. 0.81. What is the ratio of the Stocks(% of exports of goods, services and primary income) in Ecuador in 2007 to that in 2009?
Provide a succinct answer. 1.31. What is the ratio of the Stocks(% of exports of goods, services and primary income) in Sierra Leone in 2007 to that in 2009?
Your response must be concise. 0.65. What is the ratio of the Stocks(% of exports of goods, services and primary income) of Azerbaijan in 2008 to that in 2009?
Make the answer very short. 0.67. What is the ratio of the Stocks(% of exports of goods, services and primary income) of Ecuador in 2008 to that in 2009?
Your answer should be compact. 0.9. What is the ratio of the Stocks(% of exports of goods, services and primary income) in Sierra Leone in 2008 to that in 2009?
Keep it short and to the point. 0.81. What is the difference between the highest and the second highest Stocks(% of exports of goods, services and primary income) of Azerbaijan?
Offer a very short reply. 0.19. What is the difference between the highest and the second highest Stocks(% of exports of goods, services and primary income) of Ecuador?
Your answer should be very brief. 35.14. What is the difference between the highest and the second highest Stocks(% of exports of goods, services and primary income) of Sierra Leone?
Your answer should be compact. 317.86. What is the difference between the highest and the lowest Stocks(% of exports of goods, services and primary income) in Azerbaijan?
Keep it short and to the point. 46.61. What is the difference between the highest and the lowest Stocks(% of exports of goods, services and primary income) of Ecuador?
Your response must be concise. 186.04. What is the difference between the highest and the lowest Stocks(% of exports of goods, services and primary income) in Sierra Leone?
Keep it short and to the point. 1036.91. 